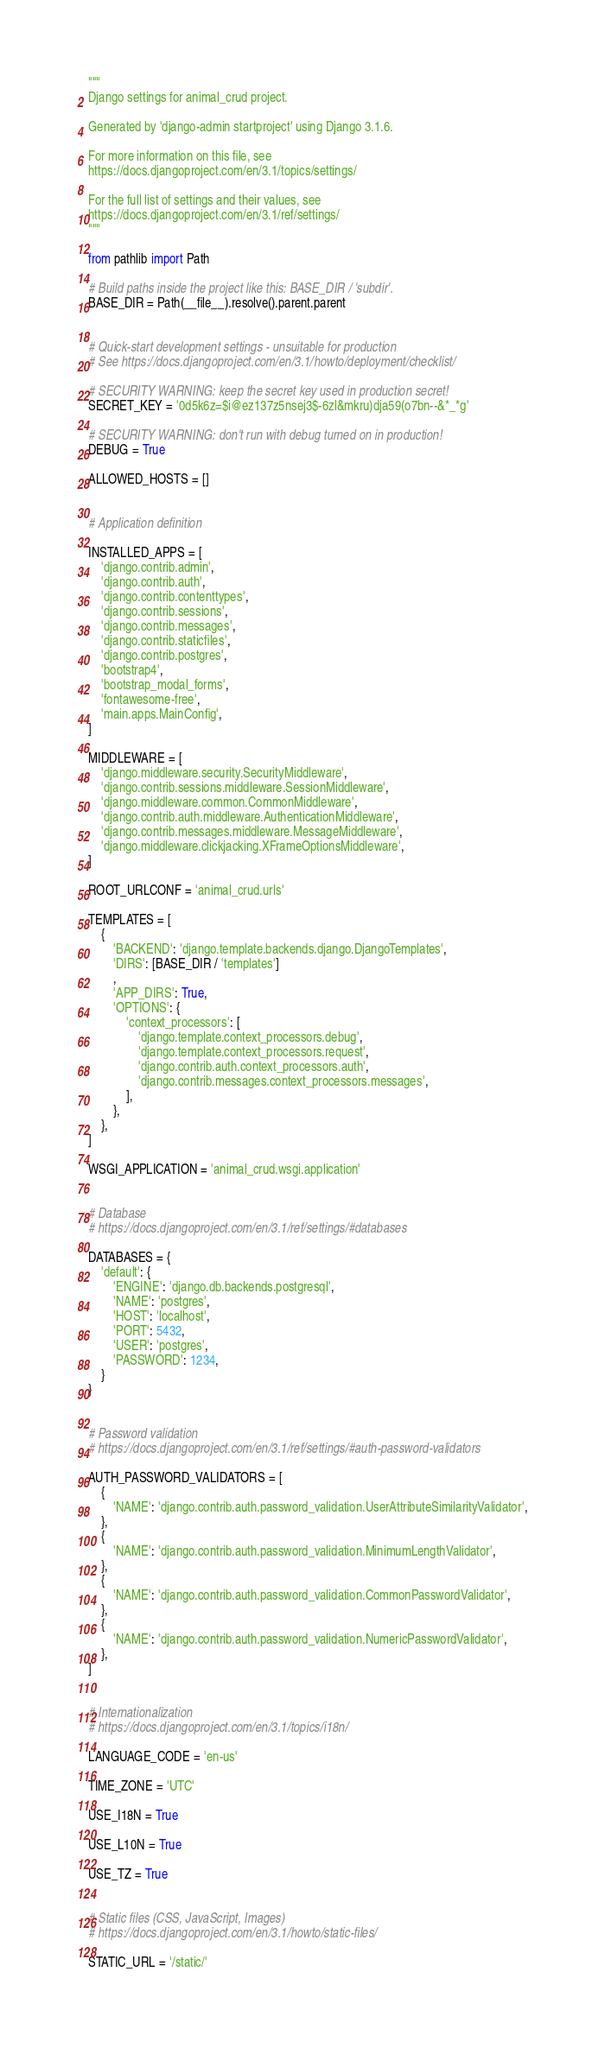<code> <loc_0><loc_0><loc_500><loc_500><_Python_>"""
Django settings for animal_crud project.

Generated by 'django-admin startproject' using Django 3.1.6.

For more information on this file, see
https://docs.djangoproject.com/en/3.1/topics/settings/

For the full list of settings and their values, see
https://docs.djangoproject.com/en/3.1/ref/settings/
"""

from pathlib import Path

# Build paths inside the project like this: BASE_DIR / 'subdir'.
BASE_DIR = Path(__file__).resolve().parent.parent


# Quick-start development settings - unsuitable for production
# See https://docs.djangoproject.com/en/3.1/howto/deployment/checklist/

# SECURITY WARNING: keep the secret key used in production secret!
SECRET_KEY = '0d5k6z=$i@ez137z5nsej3$-6zl&mkru)dja59(o7bn--&*_*g'

# SECURITY WARNING: don't run with debug turned on in production!
DEBUG = True

ALLOWED_HOSTS = []


# Application definition

INSTALLED_APPS = [
    'django.contrib.admin',
    'django.contrib.auth',
    'django.contrib.contenttypes',
    'django.contrib.sessions',
    'django.contrib.messages',
    'django.contrib.staticfiles',
    'django.contrib.postgres',
    'bootstrap4',
    'bootstrap_modal_forms',
    'fontawesome-free',
    'main.apps.MainConfig',
]

MIDDLEWARE = [
    'django.middleware.security.SecurityMiddleware',
    'django.contrib.sessions.middleware.SessionMiddleware',
    'django.middleware.common.CommonMiddleware',
    'django.contrib.auth.middleware.AuthenticationMiddleware',
    'django.contrib.messages.middleware.MessageMiddleware',
    'django.middleware.clickjacking.XFrameOptionsMiddleware',
]

ROOT_URLCONF = 'animal_crud.urls'

TEMPLATES = [
    {
        'BACKEND': 'django.template.backends.django.DjangoTemplates',
        'DIRS': [BASE_DIR / 'templates']
        ,
        'APP_DIRS': True,
        'OPTIONS': {
            'context_processors': [
                'django.template.context_processors.debug',
                'django.template.context_processors.request',
                'django.contrib.auth.context_processors.auth',
                'django.contrib.messages.context_processors.messages',
            ],
        },
    },
]

WSGI_APPLICATION = 'animal_crud.wsgi.application'


# Database
# https://docs.djangoproject.com/en/3.1/ref/settings/#databases

DATABASES = {
    'default': {
        'ENGINE': 'django.db.backends.postgresql',
        'NAME': 'postgres',
        'HOST': 'localhost',
        'PORT': 5432,
        'USER': 'postgres',
        'PASSWORD': 1234,
    }
}


# Password validation
# https://docs.djangoproject.com/en/3.1/ref/settings/#auth-password-validators

AUTH_PASSWORD_VALIDATORS = [
    {
        'NAME': 'django.contrib.auth.password_validation.UserAttributeSimilarityValidator',
    },
    {
        'NAME': 'django.contrib.auth.password_validation.MinimumLengthValidator',
    },
    {
        'NAME': 'django.contrib.auth.password_validation.CommonPasswordValidator',
    },
    {
        'NAME': 'django.contrib.auth.password_validation.NumericPasswordValidator',
    },
]


# Internationalization
# https://docs.djangoproject.com/en/3.1/topics/i18n/

LANGUAGE_CODE = 'en-us'

TIME_ZONE = 'UTC'

USE_I18N = True

USE_L10N = True

USE_TZ = True


# Static files (CSS, JavaScript, Images)
# https://docs.djangoproject.com/en/3.1/howto/static-files/

STATIC_URL = '/static/'
</code> 